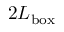Convert formula to latex. <formula><loc_0><loc_0><loc_500><loc_500>2 L _ { b o x }</formula> 